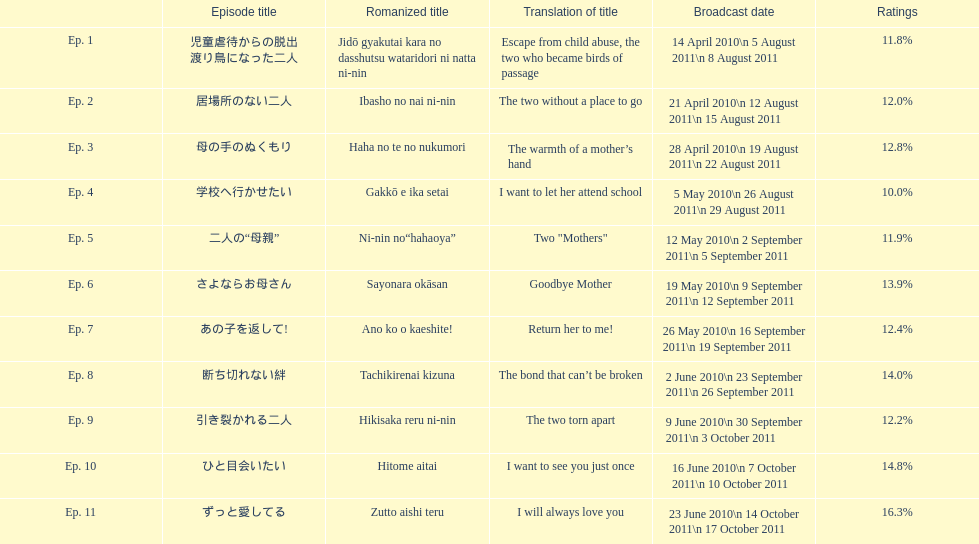Which episode had the title "i want to let her attend school"? Ep. 4. 